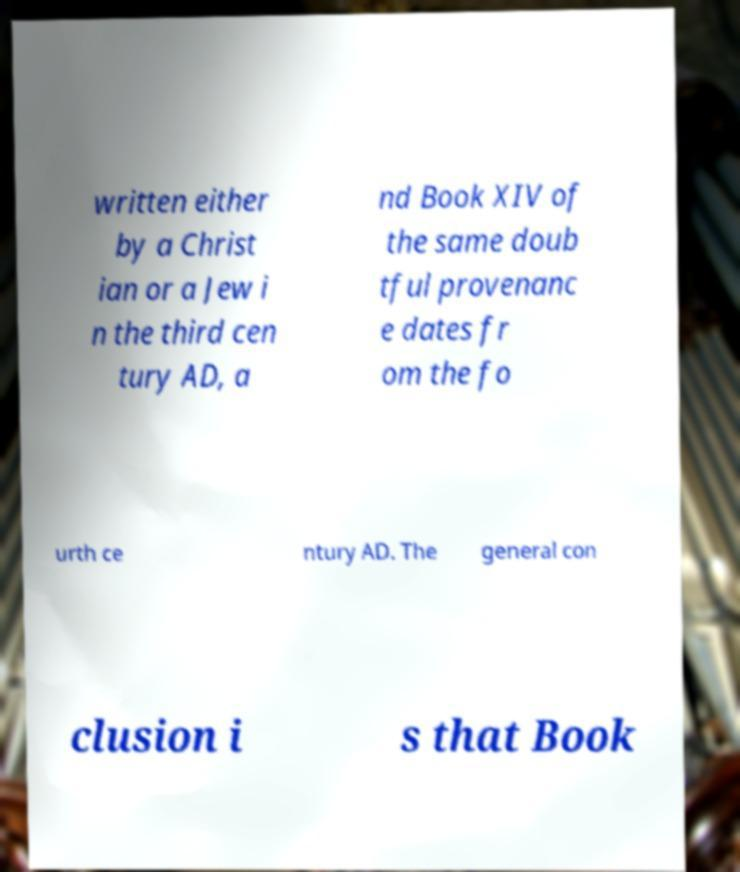I need the written content from this picture converted into text. Can you do that? written either by a Christ ian or a Jew i n the third cen tury AD, a nd Book XIV of the same doub tful provenanc e dates fr om the fo urth ce ntury AD. The general con clusion i s that Book 